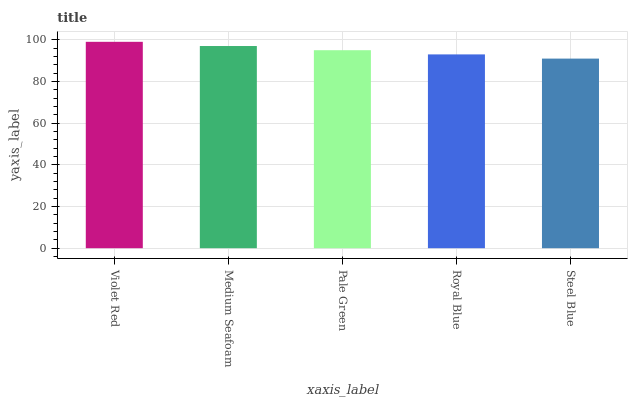Is Steel Blue the minimum?
Answer yes or no. Yes. Is Violet Red the maximum?
Answer yes or no. Yes. Is Medium Seafoam the minimum?
Answer yes or no. No. Is Medium Seafoam the maximum?
Answer yes or no. No. Is Violet Red greater than Medium Seafoam?
Answer yes or no. Yes. Is Medium Seafoam less than Violet Red?
Answer yes or no. Yes. Is Medium Seafoam greater than Violet Red?
Answer yes or no. No. Is Violet Red less than Medium Seafoam?
Answer yes or no. No. Is Pale Green the high median?
Answer yes or no. Yes. Is Pale Green the low median?
Answer yes or no. Yes. Is Steel Blue the high median?
Answer yes or no. No. Is Steel Blue the low median?
Answer yes or no. No. 